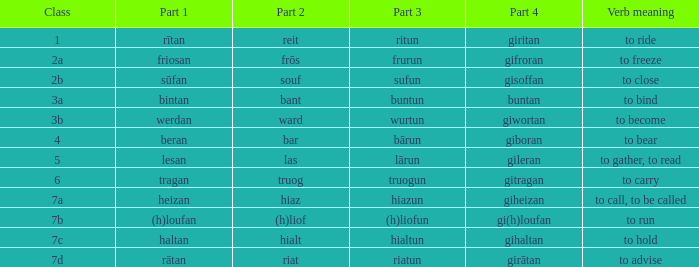What class in the word with part 4 "giheizan"? 7a. Can you give me this table as a dict? {'header': ['Class', 'Part 1', 'Part 2', 'Part 3', 'Part 4', 'Verb meaning'], 'rows': [['1', 'rītan', 'reit', 'ritun', 'giritan', 'to ride'], ['2a', 'friosan', 'frōs', 'frurun', 'gifroran', 'to freeze'], ['2b', 'sūfan', 'souf', 'sufun', 'gisoffan', 'to close'], ['3a', 'bintan', 'bant', 'buntun', 'buntan', 'to bind'], ['3b', 'werdan', 'ward', 'wurtun', 'giwortan', 'to become'], ['4', 'beran', 'bar', 'bārun', 'giboran', 'to bear'], ['5', 'lesan', 'las', 'lārun', 'gileran', 'to gather, to read'], ['6', 'tragan', 'truog', 'truogun', 'gitragan', 'to carry'], ['7a', 'heizan', 'hiaz', 'hiazun', 'giheizan', 'to call, to be called'], ['7b', '(h)loufan', '(h)liof', '(h)liofun', 'gi(h)loufan', 'to run'], ['7c', 'haltan', 'hialt', 'hialtun', 'gihaltan', 'to hold'], ['7d', 'rātan', 'riat', 'riatun', 'girātan', 'to advise']]} 